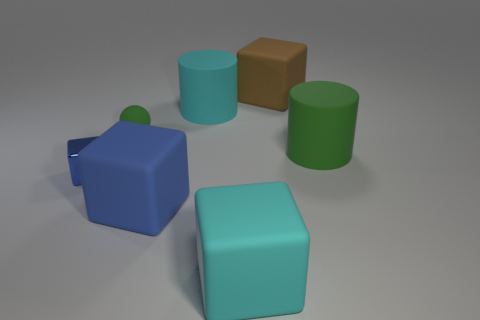Add 2 small shiny cubes. How many objects exist? 9 Subtract all blocks. How many objects are left? 3 Add 4 tiny brown rubber things. How many tiny brown rubber things exist? 4 Subtract 1 green balls. How many objects are left? 6 Subtract all red spheres. Subtract all green rubber objects. How many objects are left? 5 Add 7 big cubes. How many big cubes are left? 10 